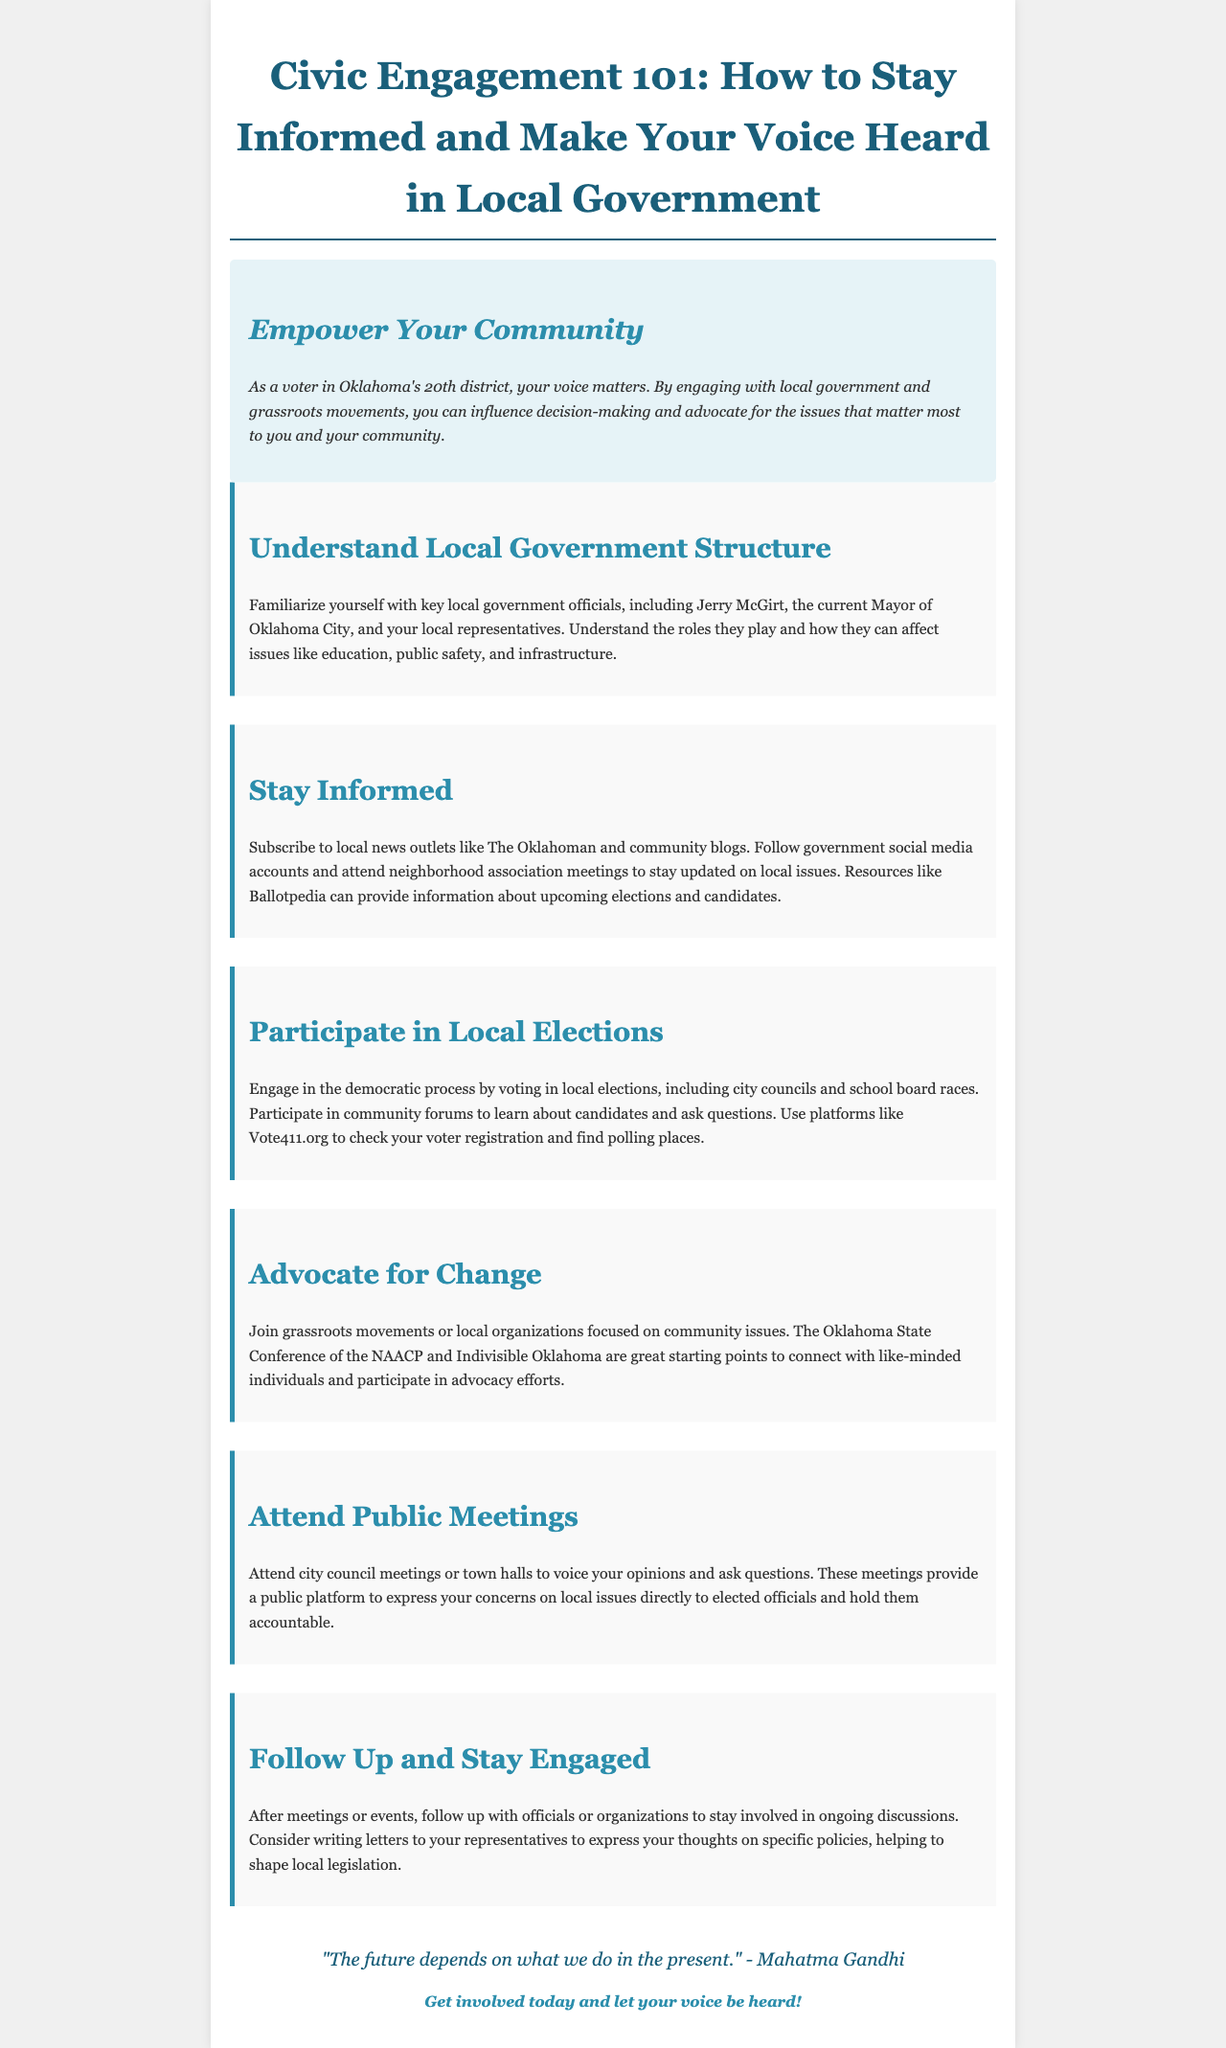What is the title of the brochure? The title of the brochure is directly given in the document's header.
Answer: Civic Engagement 101: How to Stay Informed and Make Your Voice Heard in Local Government Who is the current Mayor of Oklahoma City? The document mentions the current Mayor of Oklahoma City within the section discussing local government structure.
Answer: Jerry McGirt What is one of the local news outlets suggested for staying informed? The section on staying informed lists specific news sources to subscribe to for updates.
Answer: The Oklahoman What organization is recommended for grassroots movement involvement? The document mentions specific organizations in the section about advocating for change.
Answer: Indivisible Oklahoma What is one suggested action after attending public meetings? The document provides a follow-up recommendation after meetings in the corresponding section.
Answer: Writing letters to your representatives What is the color used for section headings in the document? The section headings have a specific color that is highlighted in the styling of the document.
Answer: #2c8eac How does the brochure categorize the theme of civic engagement? The document is organized under specific themes to help readers navigate the information.
Answer: Through sections like 'Understand Local Government Structure' and 'Advocate for Change' What is the quote mentioned at the end of the brochure? The closing section includes a quote that encapsulates the theme of engagement.
Answer: "The future depends on what we do in the present." - Mahatma Gandhi 